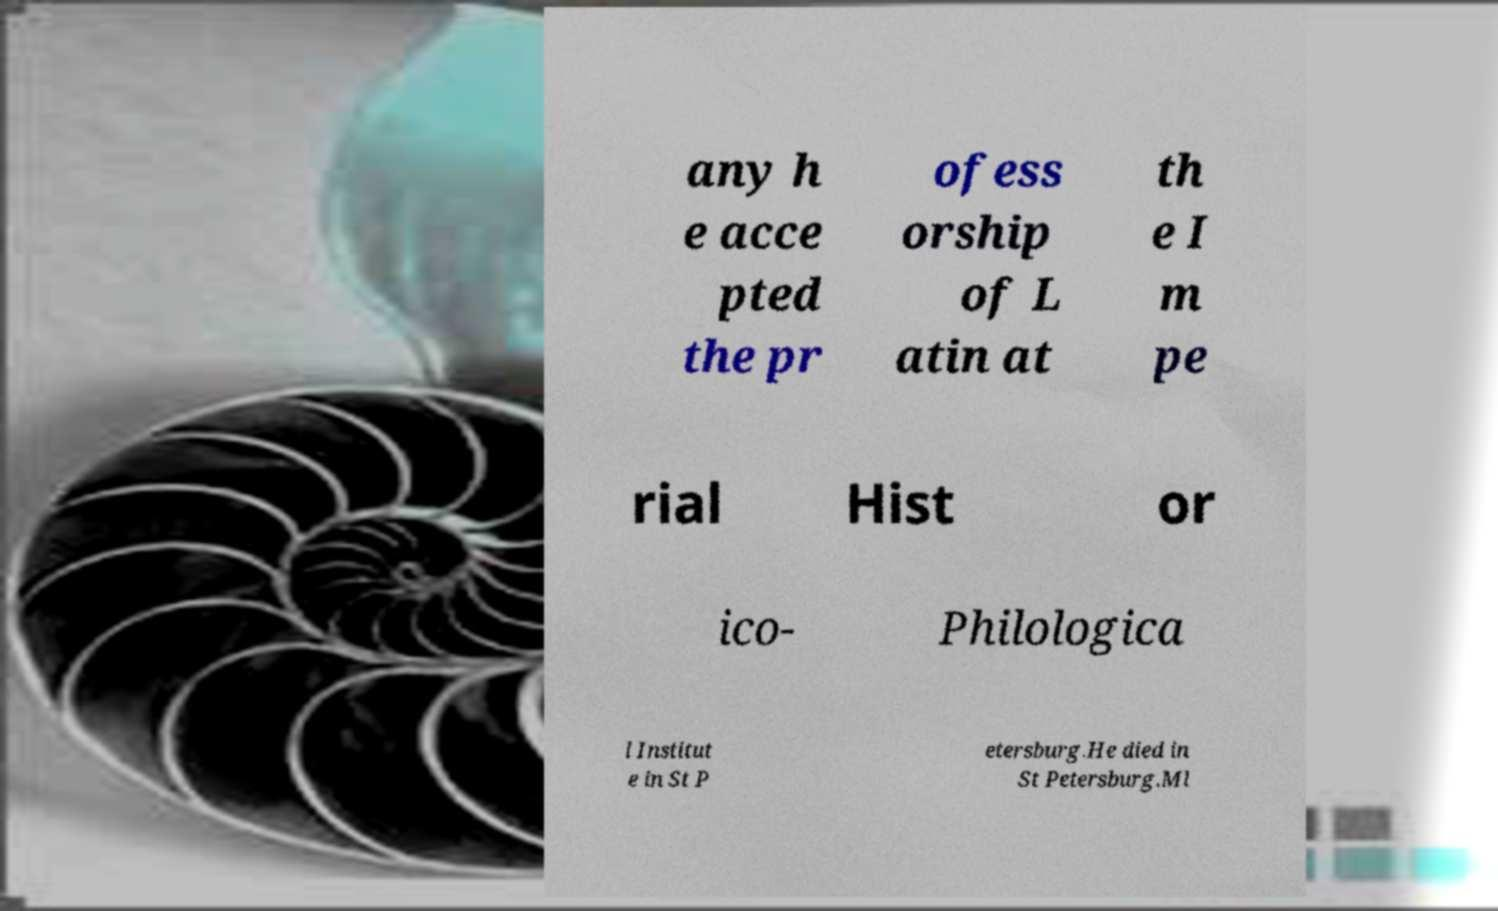What messages or text are displayed in this image? I need them in a readable, typed format. any h e acce pted the pr ofess orship of L atin at th e I m pe rial Hist or ico- Philologica l Institut e in St P etersburg.He died in St Petersburg.Ml 